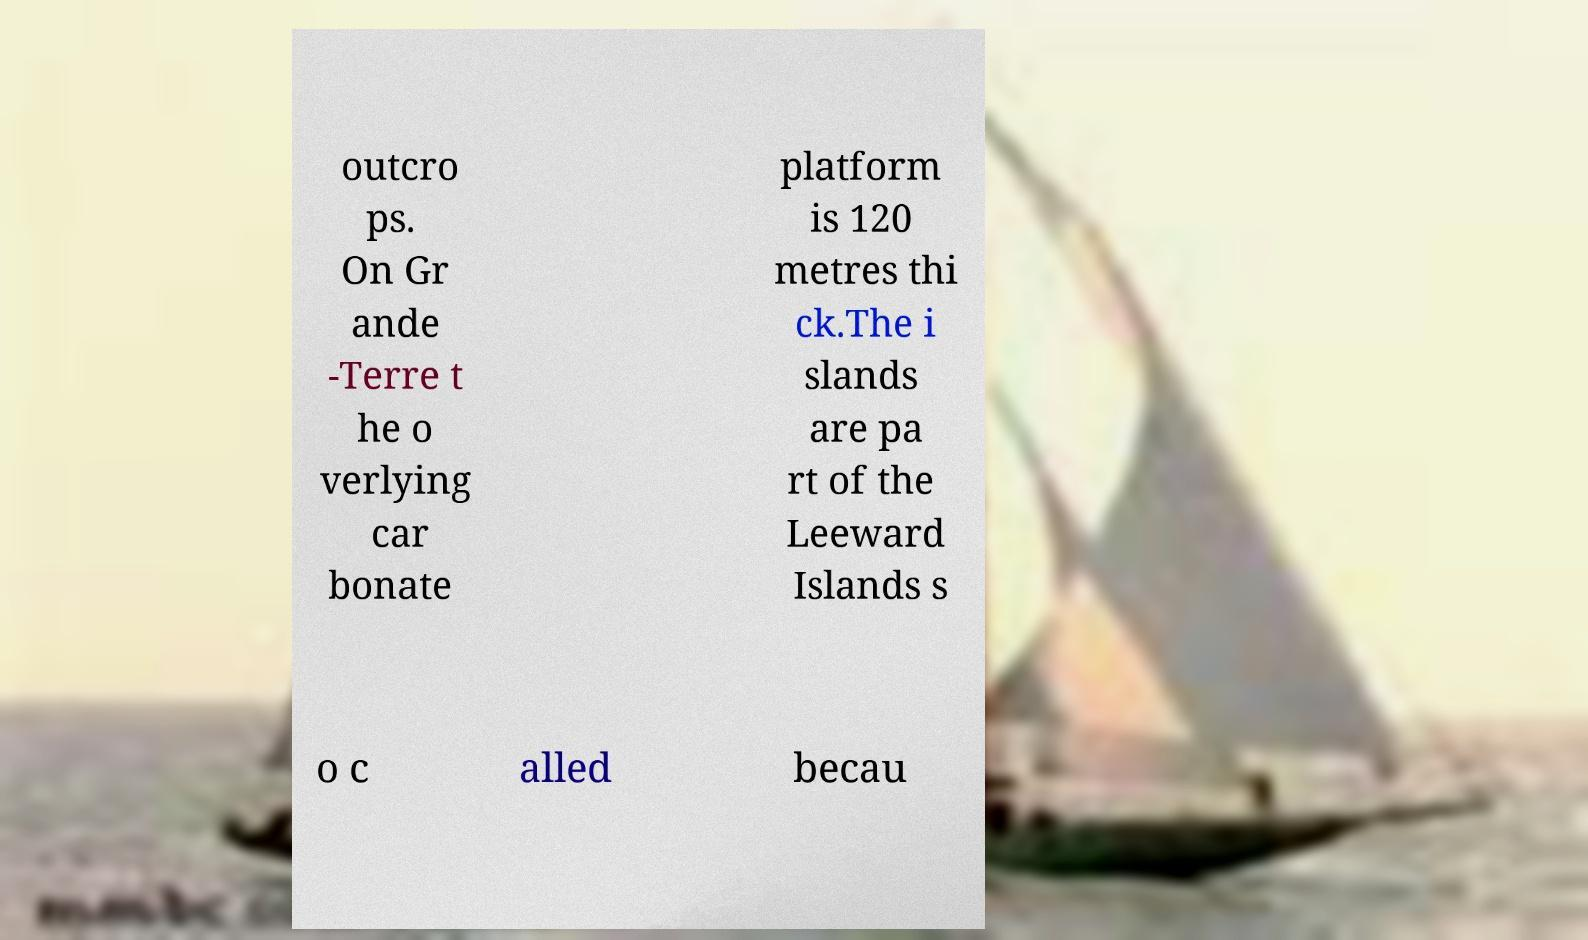There's text embedded in this image that I need extracted. Can you transcribe it verbatim? outcro ps. On Gr ande -Terre t he o verlying car bonate platform is 120 metres thi ck.The i slands are pa rt of the Leeward Islands s o c alled becau 